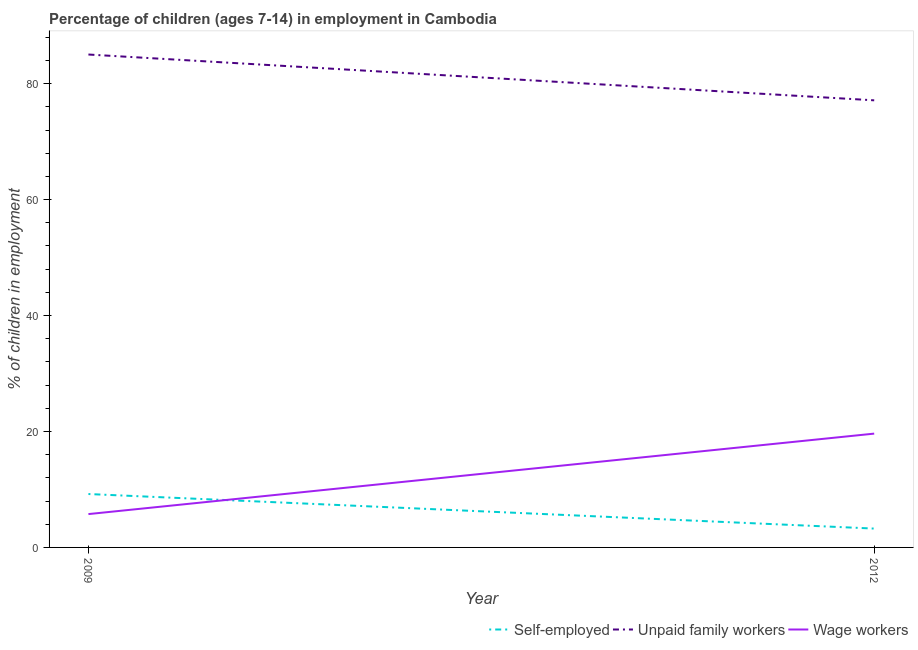How many different coloured lines are there?
Make the answer very short. 3. Does the line corresponding to percentage of children employed as wage workers intersect with the line corresponding to percentage of children employed as unpaid family workers?
Ensure brevity in your answer.  No. Is the number of lines equal to the number of legend labels?
Provide a succinct answer. Yes. What is the percentage of children employed as unpaid family workers in 2009?
Keep it short and to the point. 85.02. Across all years, what is the maximum percentage of children employed as wage workers?
Offer a terse response. 19.63. Across all years, what is the minimum percentage of children employed as unpaid family workers?
Ensure brevity in your answer.  77.12. In which year was the percentage of children employed as unpaid family workers maximum?
Give a very brief answer. 2009. What is the total percentage of children employed as wage workers in the graph?
Your response must be concise. 25.38. What is the difference between the percentage of children employed as unpaid family workers in 2009 and that in 2012?
Provide a short and direct response. 7.9. What is the difference between the percentage of self employed children in 2012 and the percentage of children employed as unpaid family workers in 2009?
Keep it short and to the point. -81.77. What is the average percentage of children employed as unpaid family workers per year?
Your answer should be very brief. 81.07. In the year 2012, what is the difference between the percentage of children employed as wage workers and percentage of children employed as unpaid family workers?
Offer a terse response. -57.49. In how many years, is the percentage of children employed as wage workers greater than 48 %?
Your response must be concise. 0. What is the ratio of the percentage of children employed as unpaid family workers in 2009 to that in 2012?
Your answer should be very brief. 1.1. Is the percentage of children employed as unpaid family workers in 2009 less than that in 2012?
Keep it short and to the point. No. In how many years, is the percentage of children employed as wage workers greater than the average percentage of children employed as wage workers taken over all years?
Offer a very short reply. 1. Is it the case that in every year, the sum of the percentage of self employed children and percentage of children employed as unpaid family workers is greater than the percentage of children employed as wage workers?
Your response must be concise. Yes. Is the percentage of children employed as wage workers strictly greater than the percentage of children employed as unpaid family workers over the years?
Offer a terse response. No. How many lines are there?
Ensure brevity in your answer.  3. How many years are there in the graph?
Give a very brief answer. 2. What is the difference between two consecutive major ticks on the Y-axis?
Offer a very short reply. 20. Are the values on the major ticks of Y-axis written in scientific E-notation?
Make the answer very short. No. Does the graph contain grids?
Offer a very short reply. No. What is the title of the graph?
Keep it short and to the point. Percentage of children (ages 7-14) in employment in Cambodia. Does "Coal" appear as one of the legend labels in the graph?
Offer a very short reply. No. What is the label or title of the X-axis?
Provide a succinct answer. Year. What is the label or title of the Y-axis?
Your answer should be very brief. % of children in employment. What is the % of children in employment of Self-employed in 2009?
Your response must be concise. 9.21. What is the % of children in employment in Unpaid family workers in 2009?
Ensure brevity in your answer.  85.02. What is the % of children in employment in Wage workers in 2009?
Your answer should be compact. 5.75. What is the % of children in employment of Self-employed in 2012?
Your answer should be very brief. 3.25. What is the % of children in employment in Unpaid family workers in 2012?
Offer a very short reply. 77.12. What is the % of children in employment of Wage workers in 2012?
Make the answer very short. 19.63. Across all years, what is the maximum % of children in employment of Self-employed?
Give a very brief answer. 9.21. Across all years, what is the maximum % of children in employment in Unpaid family workers?
Make the answer very short. 85.02. Across all years, what is the maximum % of children in employment in Wage workers?
Offer a very short reply. 19.63. Across all years, what is the minimum % of children in employment in Unpaid family workers?
Your answer should be compact. 77.12. Across all years, what is the minimum % of children in employment in Wage workers?
Your response must be concise. 5.75. What is the total % of children in employment of Self-employed in the graph?
Give a very brief answer. 12.46. What is the total % of children in employment of Unpaid family workers in the graph?
Make the answer very short. 162.14. What is the total % of children in employment of Wage workers in the graph?
Provide a short and direct response. 25.38. What is the difference between the % of children in employment of Self-employed in 2009 and that in 2012?
Your answer should be very brief. 5.96. What is the difference between the % of children in employment of Wage workers in 2009 and that in 2012?
Make the answer very short. -13.88. What is the difference between the % of children in employment in Self-employed in 2009 and the % of children in employment in Unpaid family workers in 2012?
Keep it short and to the point. -67.91. What is the difference between the % of children in employment of Self-employed in 2009 and the % of children in employment of Wage workers in 2012?
Your answer should be very brief. -10.42. What is the difference between the % of children in employment in Unpaid family workers in 2009 and the % of children in employment in Wage workers in 2012?
Offer a terse response. 65.39. What is the average % of children in employment in Self-employed per year?
Offer a very short reply. 6.23. What is the average % of children in employment of Unpaid family workers per year?
Provide a short and direct response. 81.07. What is the average % of children in employment in Wage workers per year?
Give a very brief answer. 12.69. In the year 2009, what is the difference between the % of children in employment in Self-employed and % of children in employment in Unpaid family workers?
Keep it short and to the point. -75.81. In the year 2009, what is the difference between the % of children in employment in Self-employed and % of children in employment in Wage workers?
Provide a short and direct response. 3.46. In the year 2009, what is the difference between the % of children in employment of Unpaid family workers and % of children in employment of Wage workers?
Provide a succinct answer. 79.27. In the year 2012, what is the difference between the % of children in employment in Self-employed and % of children in employment in Unpaid family workers?
Provide a succinct answer. -73.87. In the year 2012, what is the difference between the % of children in employment of Self-employed and % of children in employment of Wage workers?
Provide a succinct answer. -16.38. In the year 2012, what is the difference between the % of children in employment in Unpaid family workers and % of children in employment in Wage workers?
Ensure brevity in your answer.  57.49. What is the ratio of the % of children in employment in Self-employed in 2009 to that in 2012?
Offer a terse response. 2.83. What is the ratio of the % of children in employment in Unpaid family workers in 2009 to that in 2012?
Offer a very short reply. 1.1. What is the ratio of the % of children in employment in Wage workers in 2009 to that in 2012?
Offer a terse response. 0.29. What is the difference between the highest and the second highest % of children in employment of Self-employed?
Provide a succinct answer. 5.96. What is the difference between the highest and the second highest % of children in employment of Unpaid family workers?
Make the answer very short. 7.9. What is the difference between the highest and the second highest % of children in employment in Wage workers?
Provide a succinct answer. 13.88. What is the difference between the highest and the lowest % of children in employment of Self-employed?
Give a very brief answer. 5.96. What is the difference between the highest and the lowest % of children in employment of Unpaid family workers?
Provide a short and direct response. 7.9. What is the difference between the highest and the lowest % of children in employment in Wage workers?
Offer a terse response. 13.88. 